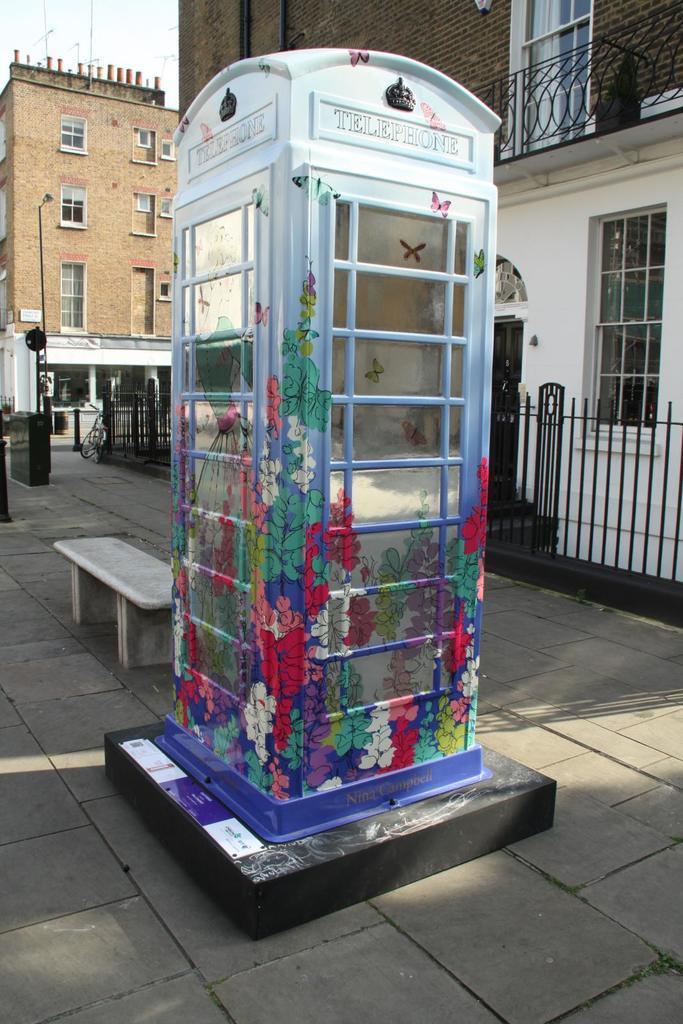Could you give a brief overview of what you see in this image? In this image I can see a white colour telephone booth, a bench, few buildings, windows and shadows. 